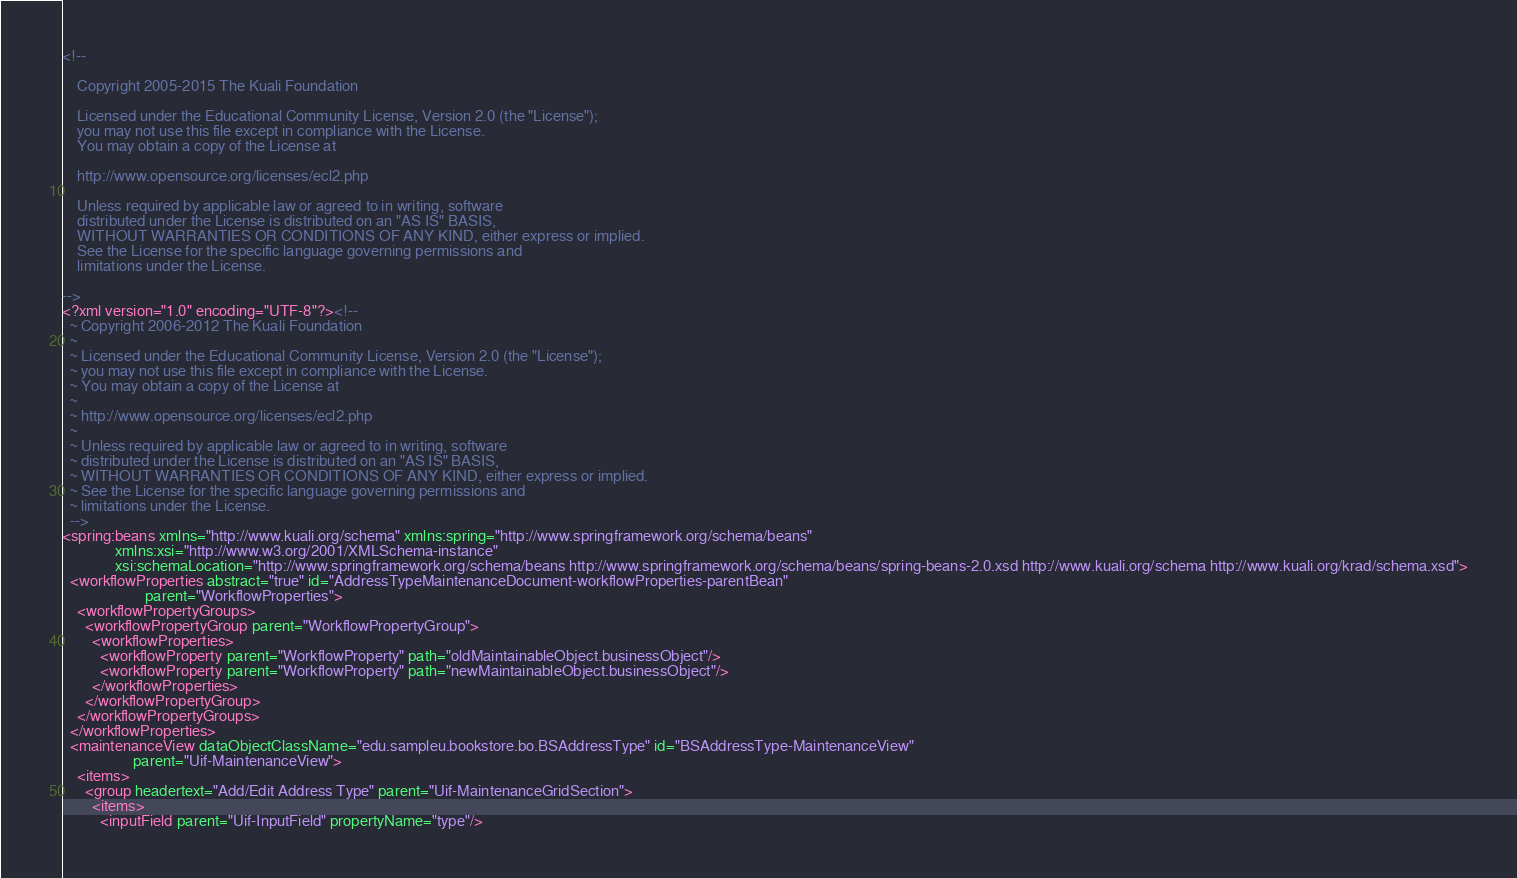<code> <loc_0><loc_0><loc_500><loc_500><_XML_><!--

    Copyright 2005-2015 The Kuali Foundation

    Licensed under the Educational Community License, Version 2.0 (the "License");
    you may not use this file except in compliance with the License.
    You may obtain a copy of the License at

    http://www.opensource.org/licenses/ecl2.php

    Unless required by applicable law or agreed to in writing, software
    distributed under the License is distributed on an "AS IS" BASIS,
    WITHOUT WARRANTIES OR CONDITIONS OF ANY KIND, either express or implied.
    See the License for the specific language governing permissions and
    limitations under the License.

-->
<?xml version="1.0" encoding="UTF-8"?><!--
  ~ Copyright 2006-2012 The Kuali Foundation
  ~
  ~ Licensed under the Educational Community License, Version 2.0 (the "License");
  ~ you may not use this file except in compliance with the License.
  ~ You may obtain a copy of the License at
  ~
  ~ http://www.opensource.org/licenses/ecl2.php
  ~
  ~ Unless required by applicable law or agreed to in writing, software
  ~ distributed under the License is distributed on an "AS IS" BASIS,
  ~ WITHOUT WARRANTIES OR CONDITIONS OF ANY KIND, either express or implied.
  ~ See the License for the specific language governing permissions and
  ~ limitations under the License.
  -->
<spring:beans xmlns="http://www.kuali.org/schema" xmlns:spring="http://www.springframework.org/schema/beans"
              xmlns:xsi="http://www.w3.org/2001/XMLSchema-instance"
              xsi:schemaLocation="http://www.springframework.org/schema/beans http://www.springframework.org/schema/beans/spring-beans-2.0.xsd http://www.kuali.org/schema http://www.kuali.org/krad/schema.xsd">
  <workflowProperties abstract="true" id="AddressTypeMaintenanceDocument-workflowProperties-parentBean"
                      parent="WorkflowProperties">
    <workflowPropertyGroups>
      <workflowPropertyGroup parent="WorkflowPropertyGroup">
        <workflowProperties>
          <workflowProperty parent="WorkflowProperty" path="oldMaintainableObject.businessObject"/>
          <workflowProperty parent="WorkflowProperty" path="newMaintainableObject.businessObject"/>
        </workflowProperties>
      </workflowPropertyGroup>
    </workflowPropertyGroups>
  </workflowProperties>
  <maintenanceView dataObjectClassName="edu.sampleu.bookstore.bo.BSAddressType" id="BSAddressType-MaintenanceView"
                   parent="Uif-MaintenanceView">
    <items>
      <group headertext="Add/Edit Address Type" parent="Uif-MaintenanceGridSection">
        <items>
          <inputField parent="Uif-InputField" propertyName="type"/></code> 